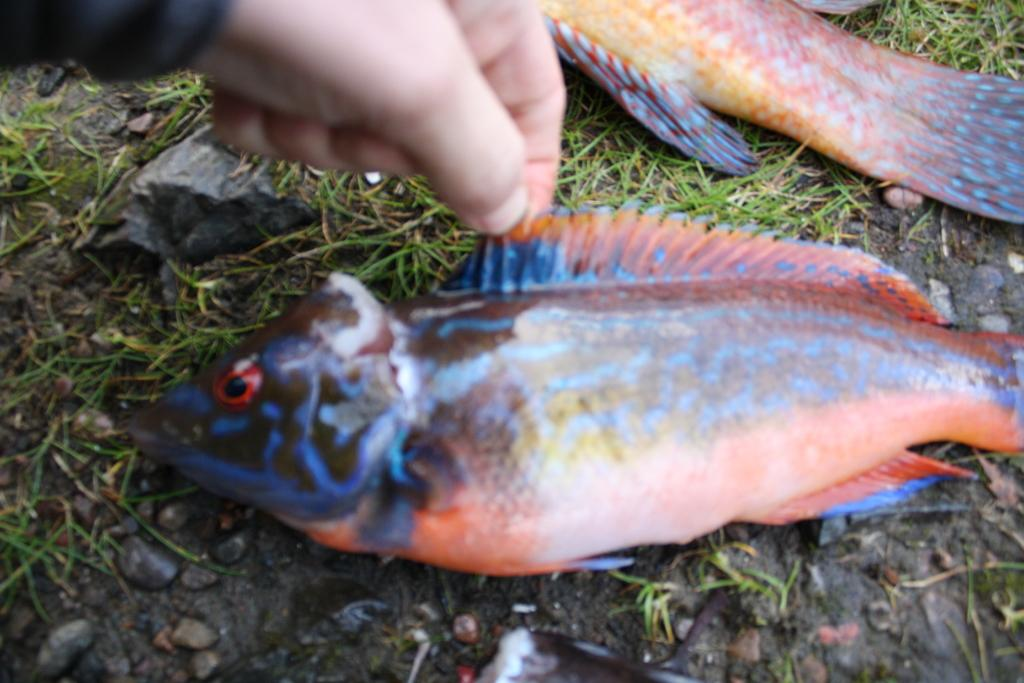What part of a person is visible in the image? There is a person's hand in the image. What animals can be seen on the grass in the image? There are two fishes on the grass in the image. What type of objects are present at the bottom of the image? There are stones at the bottom of the image. Where is the airport located in the image? There is no airport present in the image. How many pins can be seen in the image? There are no pins visible in the image. 